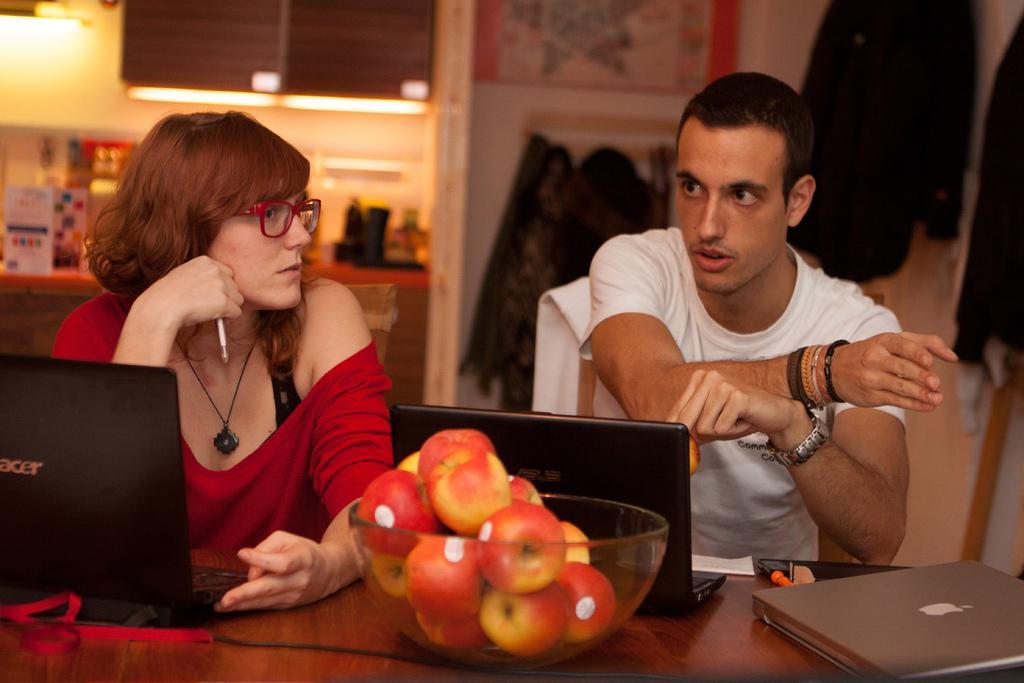How would you summarize this image in a sentence or two? In this picture we can see two persons sitting on the chairs. This is table. On the table there are laptops, fruits, and a bowl. On the background we can see a light. And this is wall. 